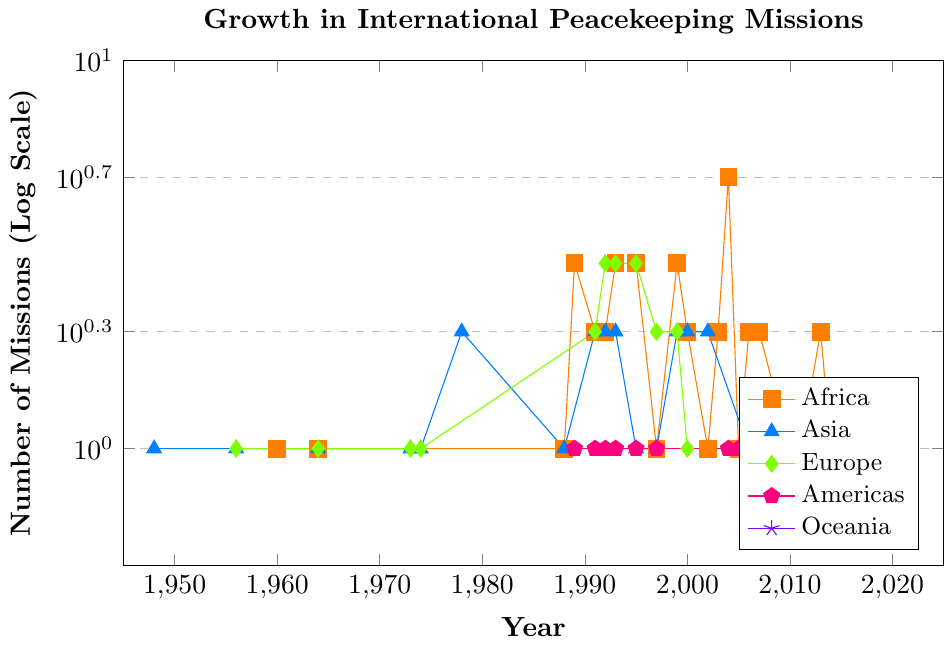Which continent had the highest number of missions in 2004? Look at the year 2004 on the x-axis, and then compare the y-values of the different colored lines. Africa has the highest number of missions in 2004.
Answer: Africa What is the average number of missions in Africa from 1999 to 2007? List the data points for Africa from 1999 to 2007: (3 in 1999, 2 in 2000, 1 in 2002, 2 in 2003, 5 in 2004, 1 in 2005, 2 in 2006, and 2 in 2007). Sum is 3 + 2 + 1 + 2 + 5 + 1 + 2 + 2 = 18. There are 8 data points, so the average is 18/8.
Answer: 2.25 How many more missions were in Africa than in Asia in 1989? In 1989, Africa had 3 missions and Asia had 0. Subtract Asia's missions from Africa's missions: 3 - 0.
Answer: 3 Which continent had the first mission recorded since the UN's founding? Examine the earliest years on the x-axis. In 1948, Asia had 1 mission, while other continents had zero.
Answer: Asia How did the number of missions in Europe in 1993 compare to Africa in 1993? Look at the year 1993 on the x-axis and compare the y-values of Europe and Africa. Both had 3 missions.
Answer: Equal What is the difference in the number of missions in Africa between 1960 and 2004? In 1960, Africa had 1 mission. In 2004, Africa had 5 missions. Subtract the number in 1960 from the number in 2004: 5 - 1.
Answer: 4 In which year did Oceania have its only mission? Track the line corresponding to Oceania and identify the year it has a value other than 0. In 2011, Oceania had 1 mission.
Answer: 2011 Which two continents had an equal number of missions in 1992, and what was that number? Look at the year 1992. Europe and Asia both had 3 missions each.
Answer: Europe and Asia, 3 When did the Americas see its first recorded mission, and how many missions were there that year? Find the first non-zero point on the Americas line. In 1989, the Americas had 1 mission.
Answer: 1989, 1 What was the total number of missions in Asia and Africa combined in 2007? In 2007, Asia had 0 missions and Africa had 2. Sum these values: 0 + 2.
Answer: 2 